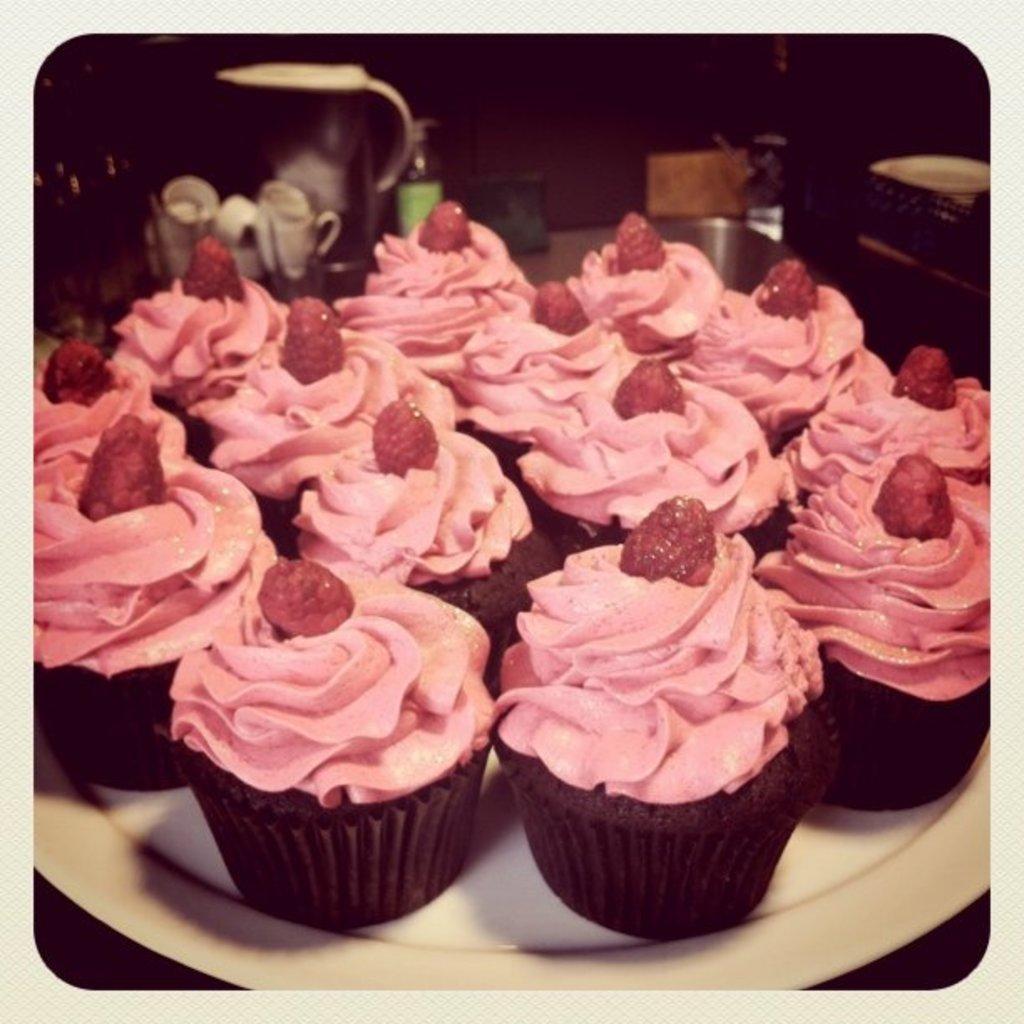Could you give a brief overview of what you see in this image? This is an edited picture. I can see cupcakes on the plate, and in the background there are some objects. 